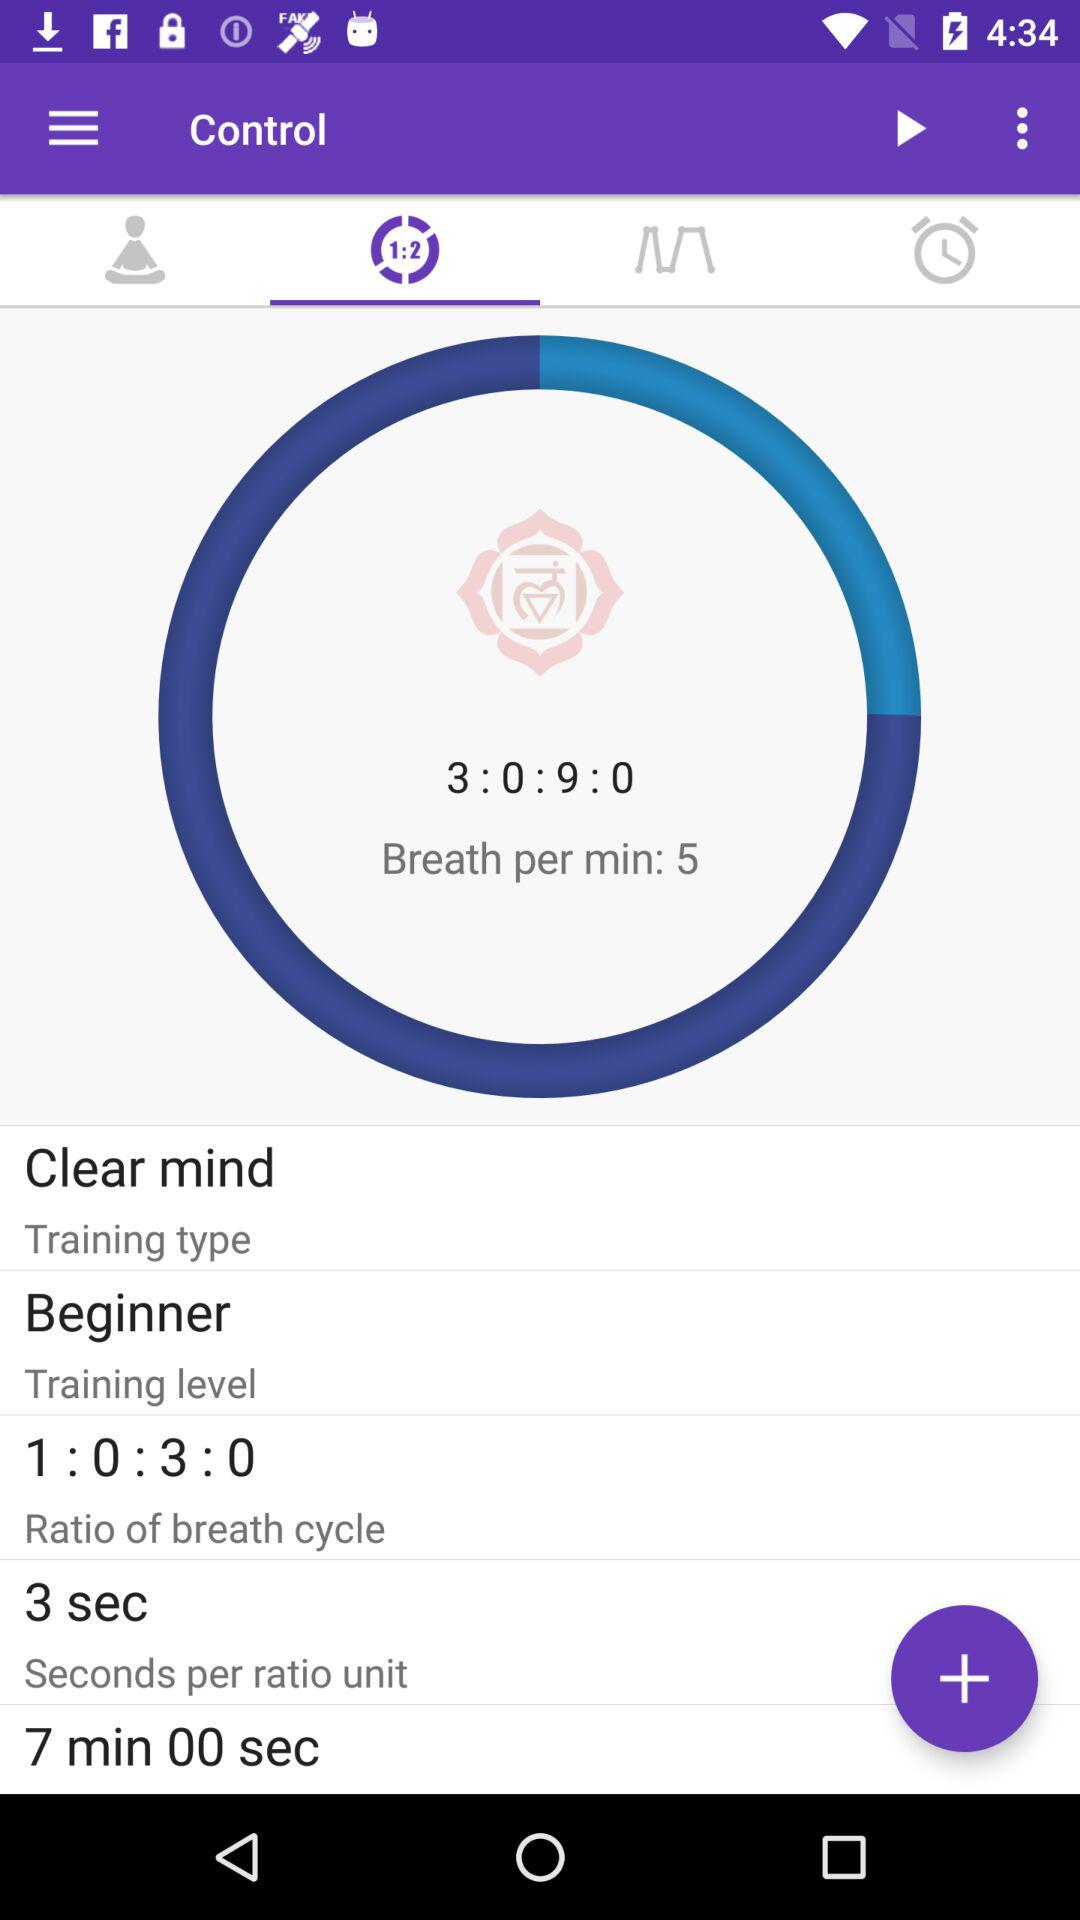How many seconds is the ratio unit?
Answer the question using a single word or phrase. 3 